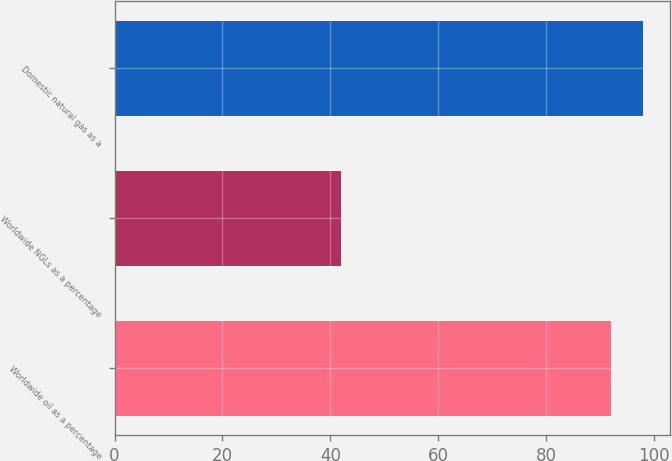<chart> <loc_0><loc_0><loc_500><loc_500><bar_chart><fcel>Worldwide oil as a percentage<fcel>Worldwide NGLs as a percentage<fcel>Domestic natural gas as a<nl><fcel>92<fcel>42<fcel>98<nl></chart> 